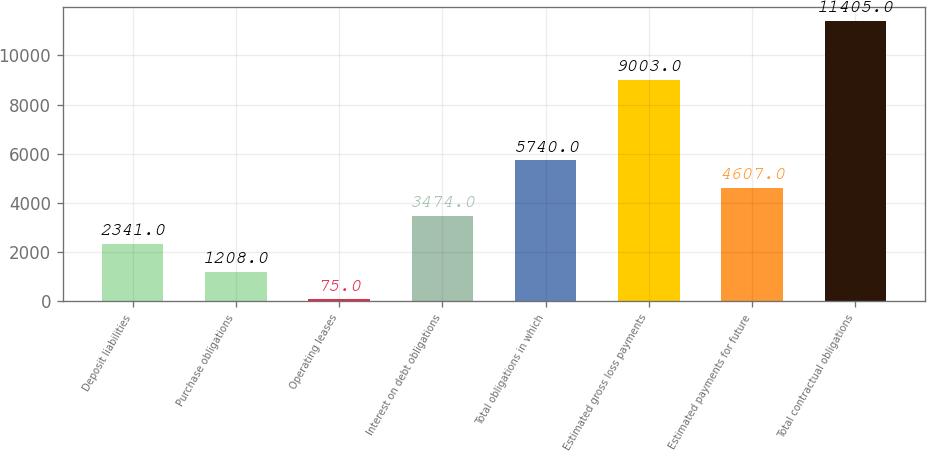Convert chart. <chart><loc_0><loc_0><loc_500><loc_500><bar_chart><fcel>Deposit liabilities<fcel>Purchase obligations<fcel>Operating leases<fcel>Interest on debt obligations<fcel>Total obligations in which<fcel>Estimated gross loss payments<fcel>Estimated payments for future<fcel>Total contractual obligations<nl><fcel>2341<fcel>1208<fcel>75<fcel>3474<fcel>5740<fcel>9003<fcel>4607<fcel>11405<nl></chart> 